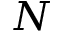<formula> <loc_0><loc_0><loc_500><loc_500>N</formula> 